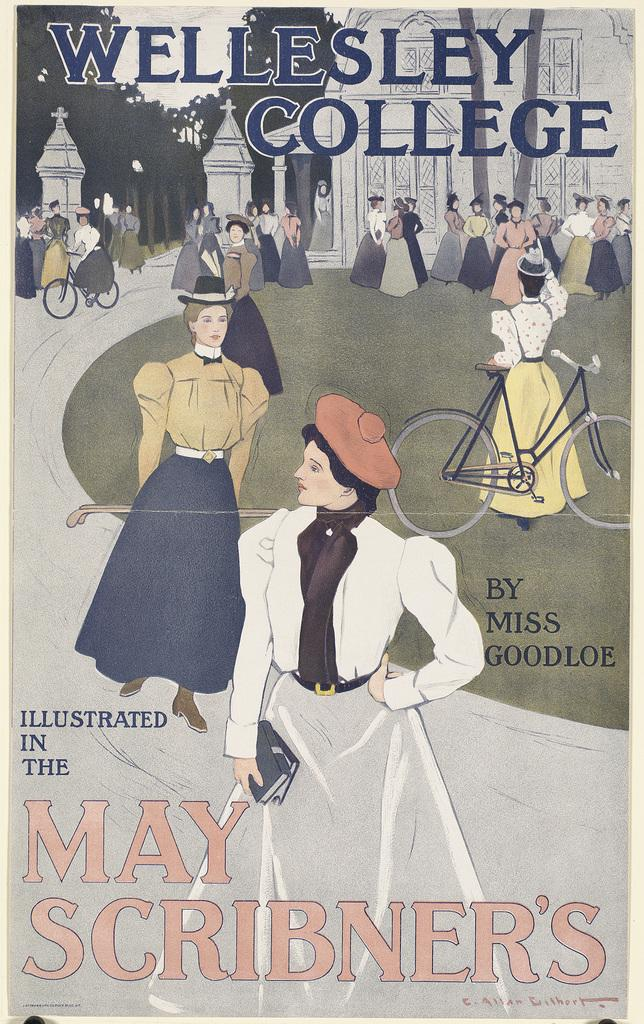<image>
Summarize the visual content of the image. the cover of the book Wellesley college by may scribner. 